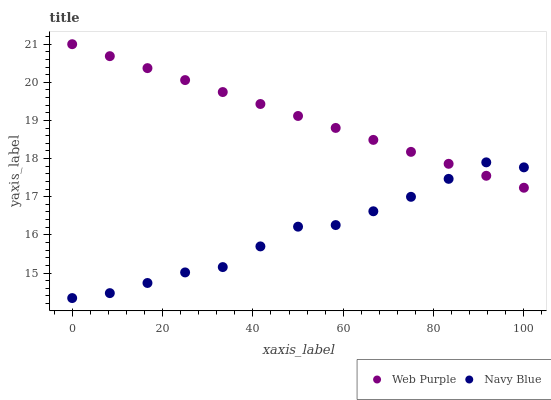Does Navy Blue have the minimum area under the curve?
Answer yes or no. Yes. Does Web Purple have the maximum area under the curve?
Answer yes or no. Yes. Does Web Purple have the minimum area under the curve?
Answer yes or no. No. Is Web Purple the smoothest?
Answer yes or no. Yes. Is Navy Blue the roughest?
Answer yes or no. Yes. Is Web Purple the roughest?
Answer yes or no. No. Does Navy Blue have the lowest value?
Answer yes or no. Yes. Does Web Purple have the lowest value?
Answer yes or no. No. Does Web Purple have the highest value?
Answer yes or no. Yes. Does Web Purple intersect Navy Blue?
Answer yes or no. Yes. Is Web Purple less than Navy Blue?
Answer yes or no. No. Is Web Purple greater than Navy Blue?
Answer yes or no. No. 